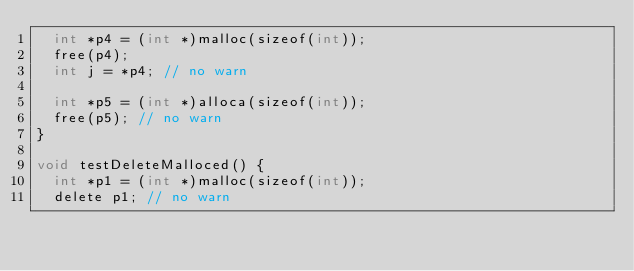<code> <loc_0><loc_0><loc_500><loc_500><_ObjectiveC_>  int *p4 = (int *)malloc(sizeof(int));
  free(p4);
  int j = *p4; // no warn

  int *p5 = (int *)alloca(sizeof(int));
  free(p5); // no warn
}

void testDeleteMalloced() {
  int *p1 = (int *)malloc(sizeof(int));
  delete p1; // no warn
</code> 